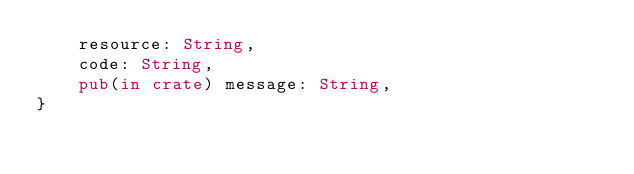<code> <loc_0><loc_0><loc_500><loc_500><_Rust_>    resource: String,
    code: String,
    pub(in crate) message: String,
}
</code> 